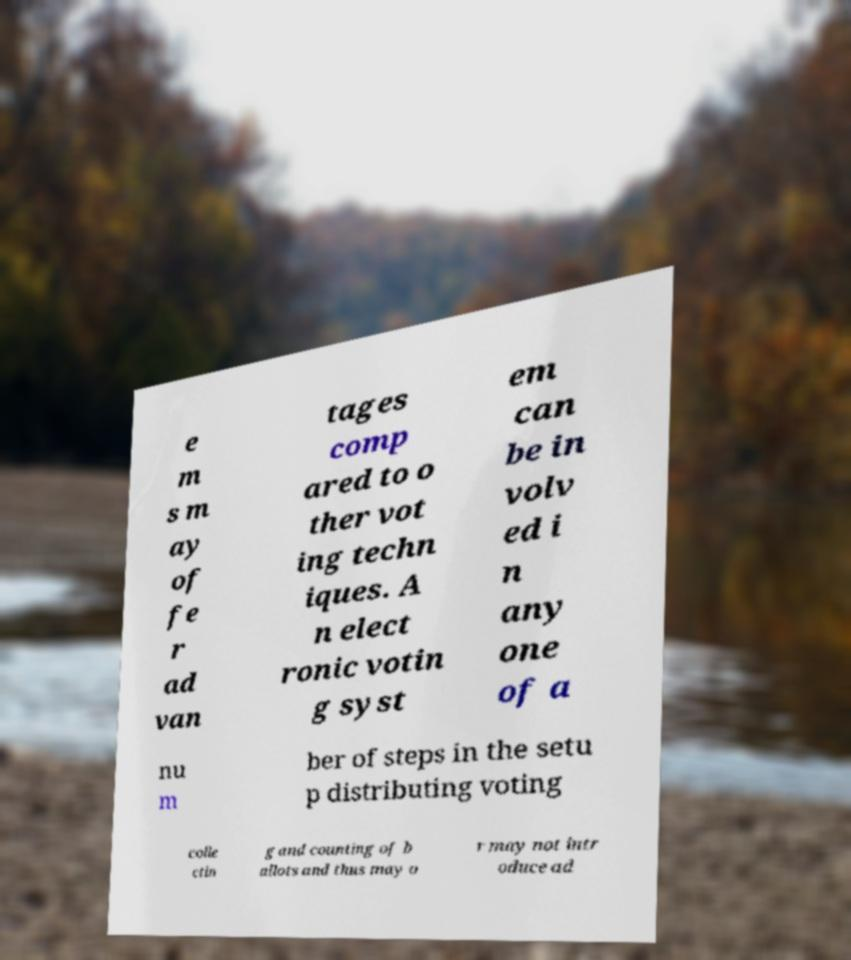For documentation purposes, I need the text within this image transcribed. Could you provide that? e m s m ay of fe r ad van tages comp ared to o ther vot ing techn iques. A n elect ronic votin g syst em can be in volv ed i n any one of a nu m ber of steps in the setu p distributing voting colle ctin g and counting of b allots and thus may o r may not intr oduce ad 